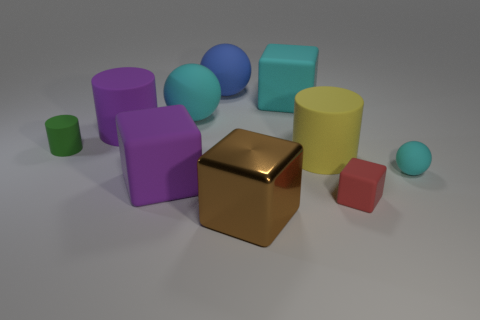There is a purple thing that is behind the green object; is it the same size as the red rubber cube?
Make the answer very short. No. What number of things are the same material as the red block?
Keep it short and to the point. 8. What is the material of the big block that is in front of the large matte object in front of the large cylinder that is in front of the small green cylinder?
Your response must be concise. Metal. There is a large cylinder that is to the right of the big brown thing that is in front of the tiny red object; what color is it?
Ensure brevity in your answer.  Yellow. There is another cylinder that is the same size as the yellow cylinder; what color is it?
Give a very brief answer. Purple. What number of large objects are either yellow rubber objects or cyan cubes?
Your answer should be very brief. 2. Is the number of red matte things left of the cyan cube greater than the number of big cyan rubber things in front of the tiny cyan matte thing?
Provide a succinct answer. No. What number of other things are the same size as the yellow cylinder?
Your response must be concise. 6. Are the cyan sphere on the left side of the big blue sphere and the purple block made of the same material?
Provide a succinct answer. Yes. How many other objects are the same color as the tiny sphere?
Offer a terse response. 2. 